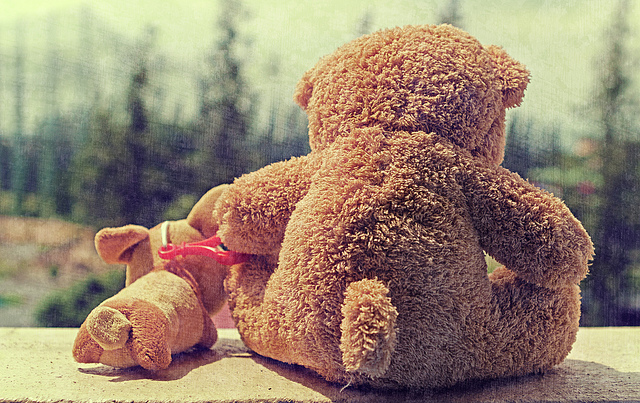What might be the story behind these two teddy bears? One could imagine that the teddy bears represent two friends or siblings. The larger bear looking out may signify its role as the protector or the more reflective one, possibly contemplating their next adventure or pondering a troubling situation. The smaller bear, with its face down, could indicate it's either resting or has faced a misfortune, awaiting comfort from its companion. 